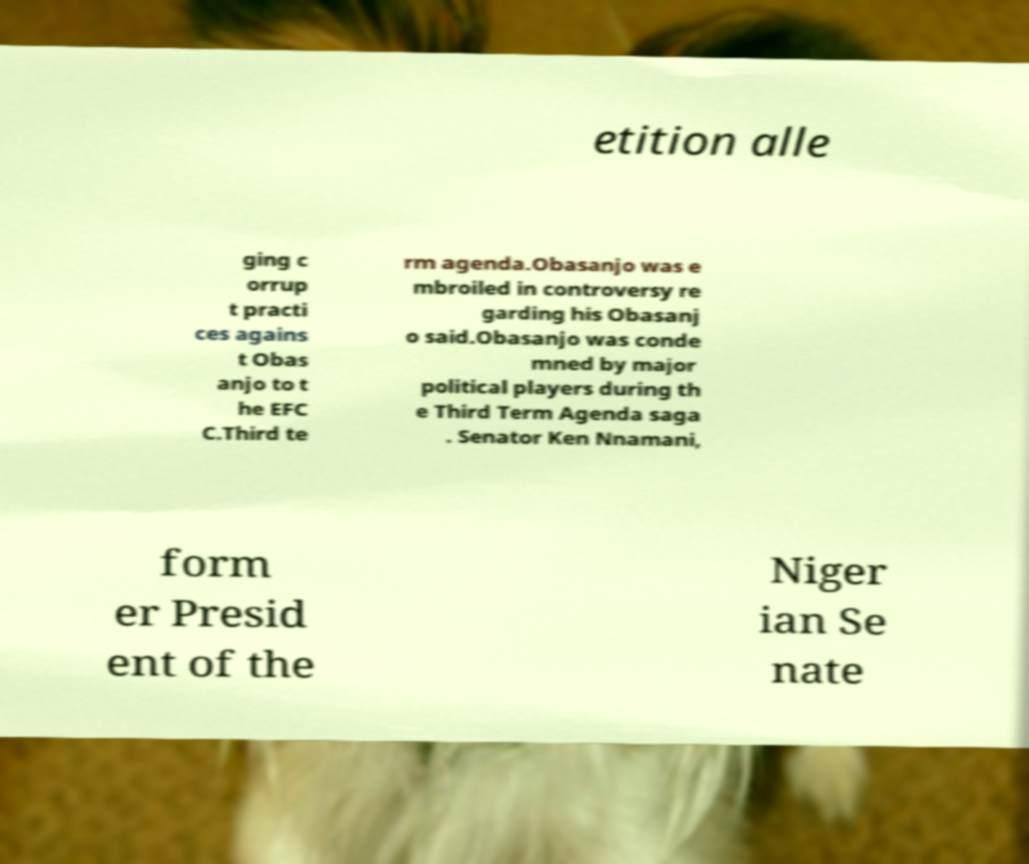Could you extract and type out the text from this image? etition alle ging c orrup t practi ces agains t Obas anjo to t he EFC C.Third te rm agenda.Obasanjo was e mbroiled in controversy re garding his Obasanj o said.Obasanjo was conde mned by major political players during th e Third Term Agenda saga . Senator Ken Nnamani, form er Presid ent of the Niger ian Se nate 